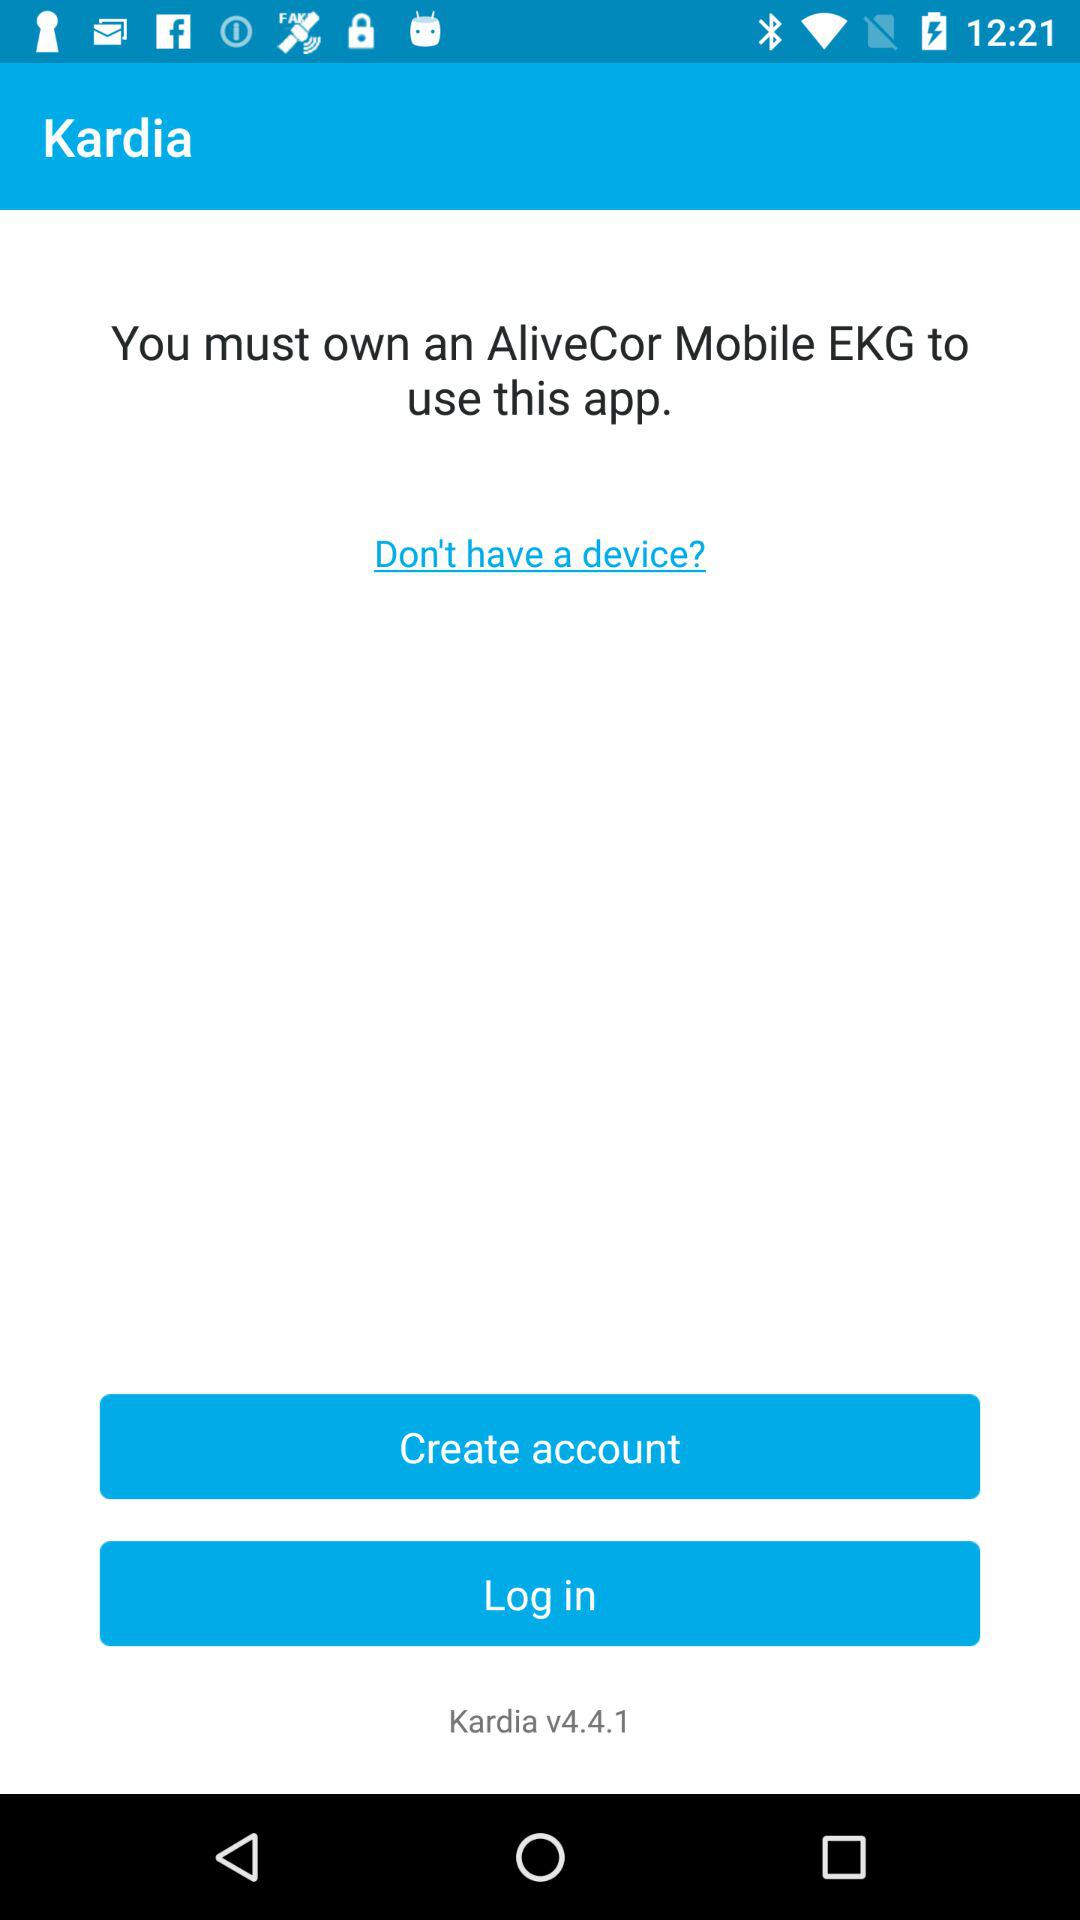Which version is used? The used version is v4.4.1. 